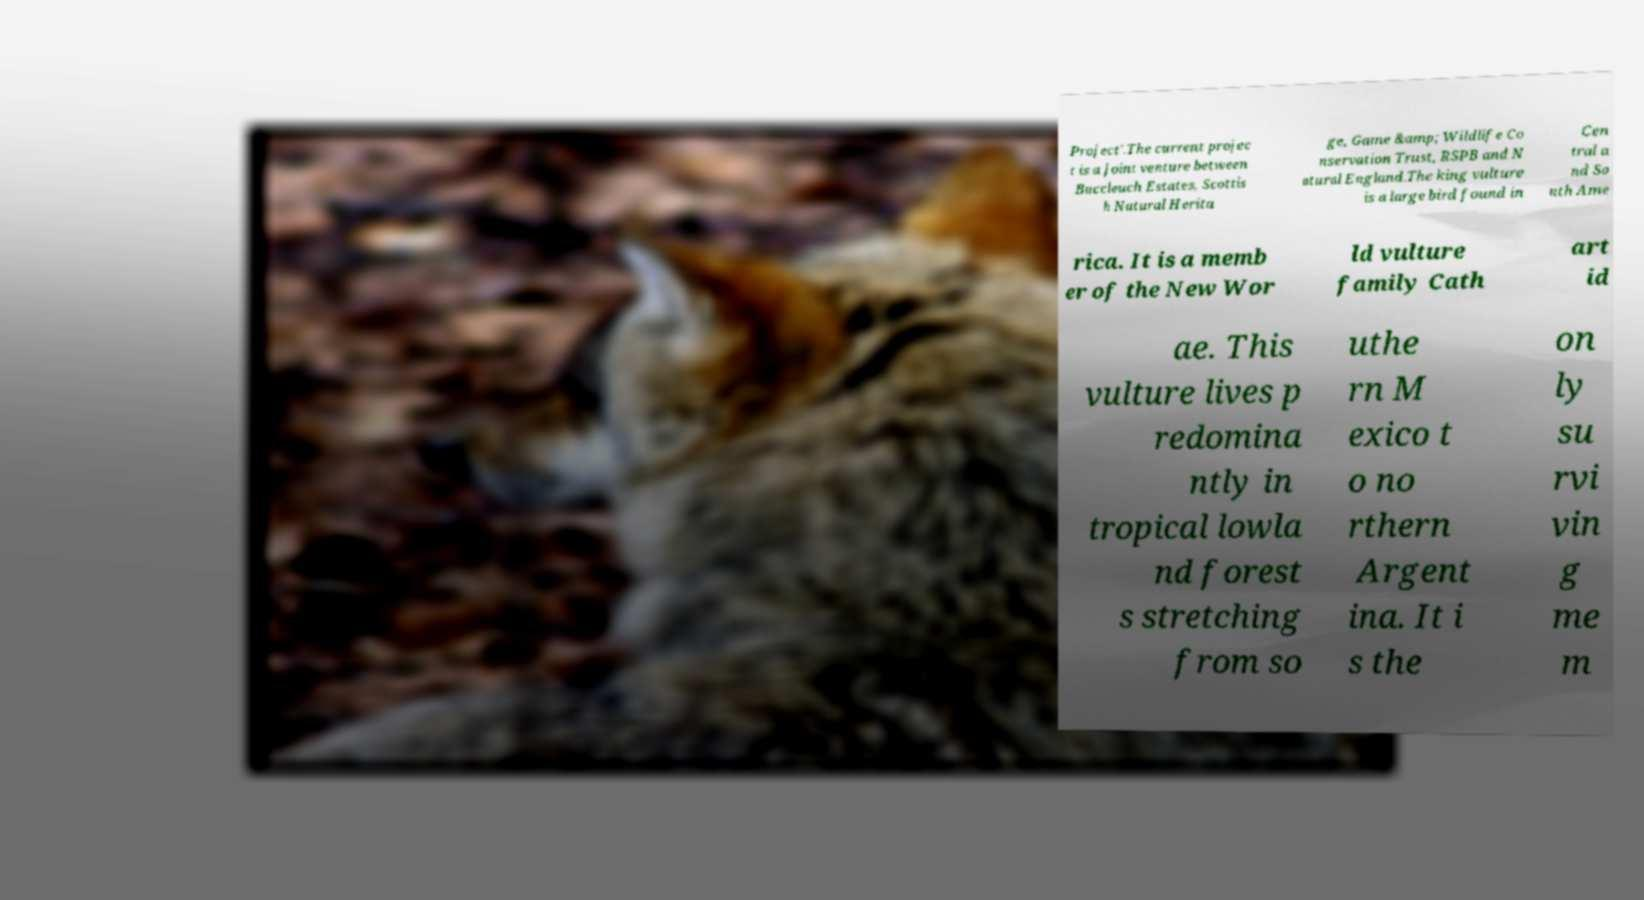Can you accurately transcribe the text from the provided image for me? Project'.The current projec t is a joint venture between Buccleuch Estates, Scottis h Natural Herita ge, Game &amp; Wildlife Co nservation Trust, RSPB and N atural England.The king vulture is a large bird found in Cen tral a nd So uth Ame rica. It is a memb er of the New Wor ld vulture family Cath art id ae. This vulture lives p redomina ntly in tropical lowla nd forest s stretching from so uthe rn M exico t o no rthern Argent ina. It i s the on ly su rvi vin g me m 